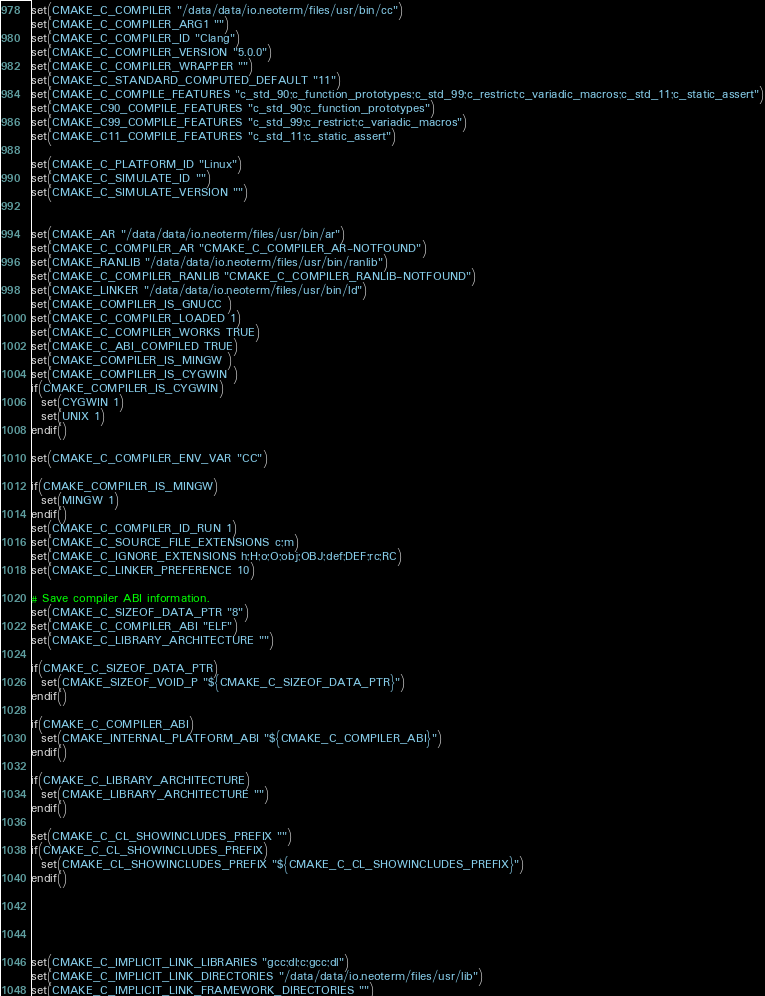Convert code to text. <code><loc_0><loc_0><loc_500><loc_500><_CMake_>set(CMAKE_C_COMPILER "/data/data/io.neoterm/files/usr/bin/cc")
set(CMAKE_C_COMPILER_ARG1 "")
set(CMAKE_C_COMPILER_ID "Clang")
set(CMAKE_C_COMPILER_VERSION "5.0.0")
set(CMAKE_C_COMPILER_WRAPPER "")
set(CMAKE_C_STANDARD_COMPUTED_DEFAULT "11")
set(CMAKE_C_COMPILE_FEATURES "c_std_90;c_function_prototypes;c_std_99;c_restrict;c_variadic_macros;c_std_11;c_static_assert")
set(CMAKE_C90_COMPILE_FEATURES "c_std_90;c_function_prototypes")
set(CMAKE_C99_COMPILE_FEATURES "c_std_99;c_restrict;c_variadic_macros")
set(CMAKE_C11_COMPILE_FEATURES "c_std_11;c_static_assert")

set(CMAKE_C_PLATFORM_ID "Linux")
set(CMAKE_C_SIMULATE_ID "")
set(CMAKE_C_SIMULATE_VERSION "")


set(CMAKE_AR "/data/data/io.neoterm/files/usr/bin/ar")
set(CMAKE_C_COMPILER_AR "CMAKE_C_COMPILER_AR-NOTFOUND")
set(CMAKE_RANLIB "/data/data/io.neoterm/files/usr/bin/ranlib")
set(CMAKE_C_COMPILER_RANLIB "CMAKE_C_COMPILER_RANLIB-NOTFOUND")
set(CMAKE_LINKER "/data/data/io.neoterm/files/usr/bin/ld")
set(CMAKE_COMPILER_IS_GNUCC )
set(CMAKE_C_COMPILER_LOADED 1)
set(CMAKE_C_COMPILER_WORKS TRUE)
set(CMAKE_C_ABI_COMPILED TRUE)
set(CMAKE_COMPILER_IS_MINGW )
set(CMAKE_COMPILER_IS_CYGWIN )
if(CMAKE_COMPILER_IS_CYGWIN)
  set(CYGWIN 1)
  set(UNIX 1)
endif()

set(CMAKE_C_COMPILER_ENV_VAR "CC")

if(CMAKE_COMPILER_IS_MINGW)
  set(MINGW 1)
endif()
set(CMAKE_C_COMPILER_ID_RUN 1)
set(CMAKE_C_SOURCE_FILE_EXTENSIONS c;m)
set(CMAKE_C_IGNORE_EXTENSIONS h;H;o;O;obj;OBJ;def;DEF;rc;RC)
set(CMAKE_C_LINKER_PREFERENCE 10)

# Save compiler ABI information.
set(CMAKE_C_SIZEOF_DATA_PTR "8")
set(CMAKE_C_COMPILER_ABI "ELF")
set(CMAKE_C_LIBRARY_ARCHITECTURE "")

if(CMAKE_C_SIZEOF_DATA_PTR)
  set(CMAKE_SIZEOF_VOID_P "${CMAKE_C_SIZEOF_DATA_PTR}")
endif()

if(CMAKE_C_COMPILER_ABI)
  set(CMAKE_INTERNAL_PLATFORM_ABI "${CMAKE_C_COMPILER_ABI}")
endif()

if(CMAKE_C_LIBRARY_ARCHITECTURE)
  set(CMAKE_LIBRARY_ARCHITECTURE "")
endif()

set(CMAKE_C_CL_SHOWINCLUDES_PREFIX "")
if(CMAKE_C_CL_SHOWINCLUDES_PREFIX)
  set(CMAKE_CL_SHOWINCLUDES_PREFIX "${CMAKE_C_CL_SHOWINCLUDES_PREFIX}")
endif()





set(CMAKE_C_IMPLICIT_LINK_LIBRARIES "gcc;dl;c;gcc;dl")
set(CMAKE_C_IMPLICIT_LINK_DIRECTORIES "/data/data/io.neoterm/files/usr/lib")
set(CMAKE_C_IMPLICIT_LINK_FRAMEWORK_DIRECTORIES "")
</code> 